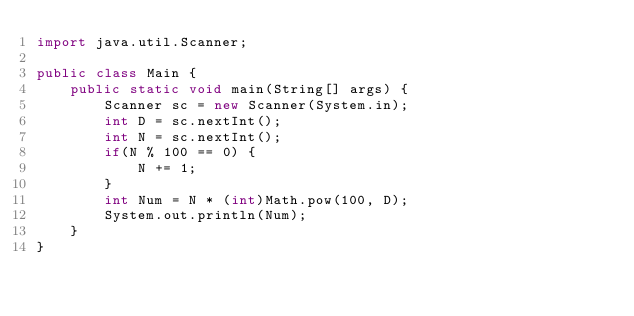<code> <loc_0><loc_0><loc_500><loc_500><_Java_>import java.util.Scanner;
 
public class Main {
	public static void main(String[] args) {
		Scanner sc = new Scanner(System.in);
		int D = sc.nextInt();
		int N = sc.nextInt();
		if(N % 100 == 0) {
			N += 1;
		}
		int Num = N * (int)Math.pow(100, D);
		System.out.println(Num);
	}
}</code> 